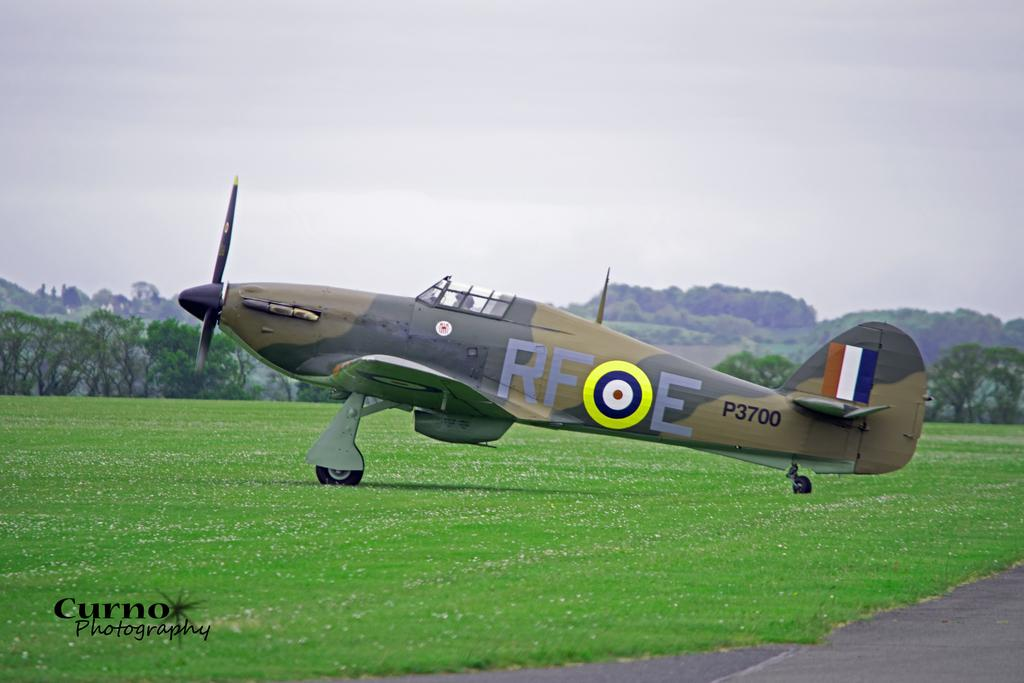What is the main subject of the image? The main subject of the image is an aircraft. Where is the aircraft located in the image? The aircraft is in a field. What can be seen in the background of the image? There are trees and the sky visible in the background of the image. Is there any text present in the image? Yes, there is text in the bottom left corner of the image. What type of substance is being recited in the verse written in the image? There is no verse or substance mentioned in the image; it features an aircraft in a field with text in the bottom left corner. 